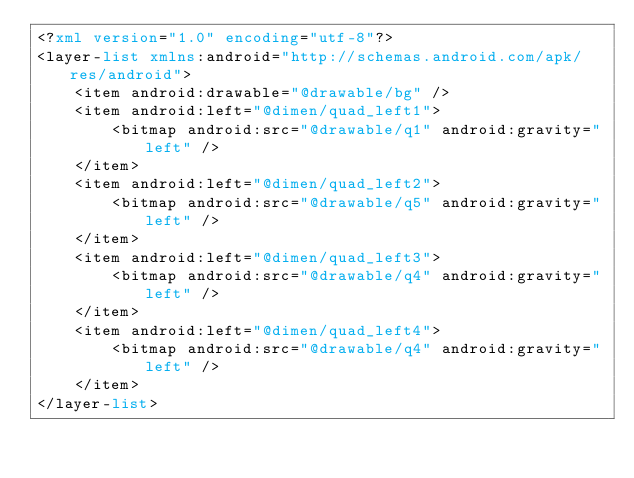Convert code to text. <code><loc_0><loc_0><loc_500><loc_500><_XML_><?xml version="1.0" encoding="utf-8"?>
<layer-list xmlns:android="http://schemas.android.com/apk/res/android">
	<item android:drawable="@drawable/bg" />
	<item android:left="@dimen/quad_left1">
	    <bitmap android:src="@drawable/q1" android:gravity="left" />
	</item>
	<item android:left="@dimen/quad_left2">
	    <bitmap android:src="@drawable/q5" android:gravity="left" />
	</item>
	<item android:left="@dimen/quad_left3">
	    <bitmap android:src="@drawable/q4" android:gravity="left" />
	</item>
	<item android:left="@dimen/quad_left4">
	    <bitmap android:src="@drawable/q4" android:gravity="left" />
	</item>
</layer-list></code> 